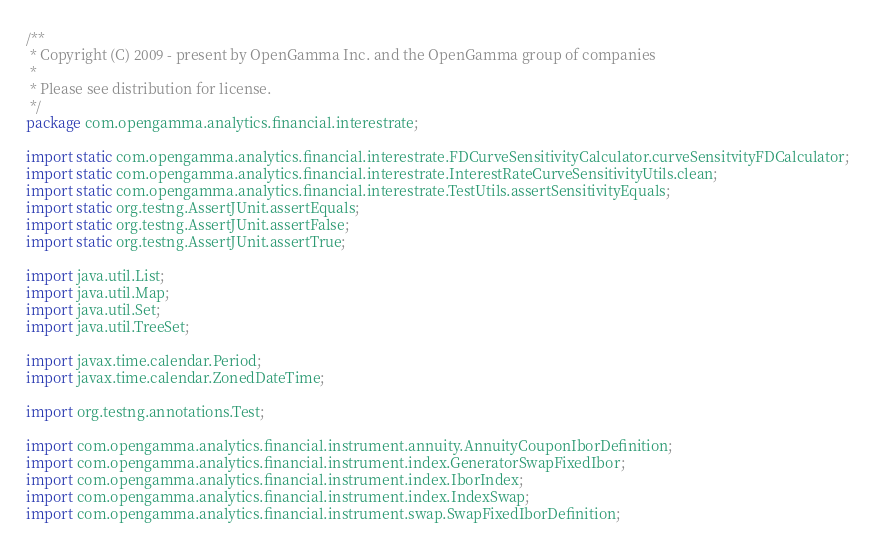<code> <loc_0><loc_0><loc_500><loc_500><_Java_>/**
 * Copyright (C) 2009 - present by OpenGamma Inc. and the OpenGamma group of companies
 * 
 * Please see distribution for license.
 */
package com.opengamma.analytics.financial.interestrate;

import static com.opengamma.analytics.financial.interestrate.FDCurveSensitivityCalculator.curveSensitvityFDCalculator;
import static com.opengamma.analytics.financial.interestrate.InterestRateCurveSensitivityUtils.clean;
import static com.opengamma.analytics.financial.interestrate.TestUtils.assertSensitivityEquals;
import static org.testng.AssertJUnit.assertEquals;
import static org.testng.AssertJUnit.assertFalse;
import static org.testng.AssertJUnit.assertTrue;

import java.util.List;
import java.util.Map;
import java.util.Set;
import java.util.TreeSet;

import javax.time.calendar.Period;
import javax.time.calendar.ZonedDateTime;

import org.testng.annotations.Test;

import com.opengamma.analytics.financial.instrument.annuity.AnnuityCouponIborDefinition;
import com.opengamma.analytics.financial.instrument.index.GeneratorSwapFixedIbor;
import com.opengamma.analytics.financial.instrument.index.IborIndex;
import com.opengamma.analytics.financial.instrument.index.IndexSwap;
import com.opengamma.analytics.financial.instrument.swap.SwapFixedIborDefinition;</code> 